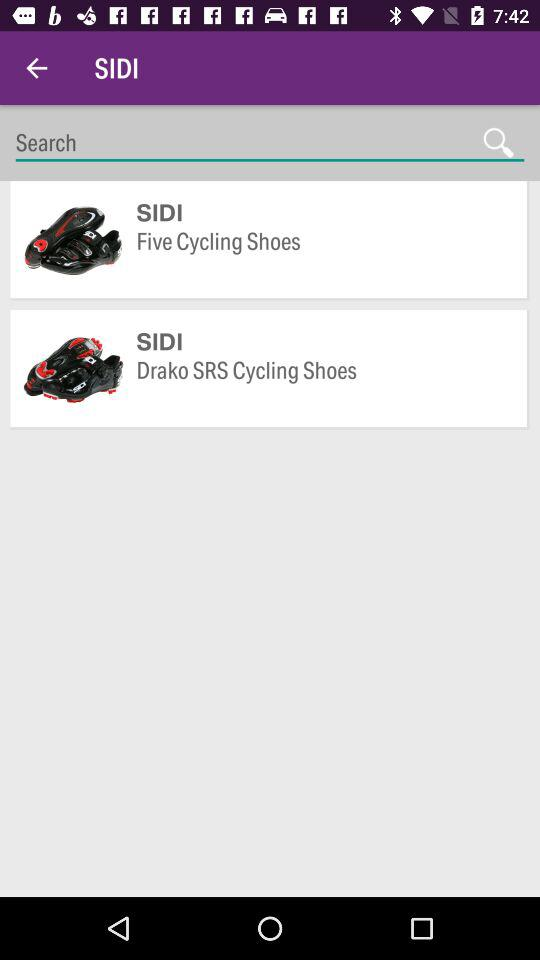What is the name of the application? The name of the application is "SIDI". 